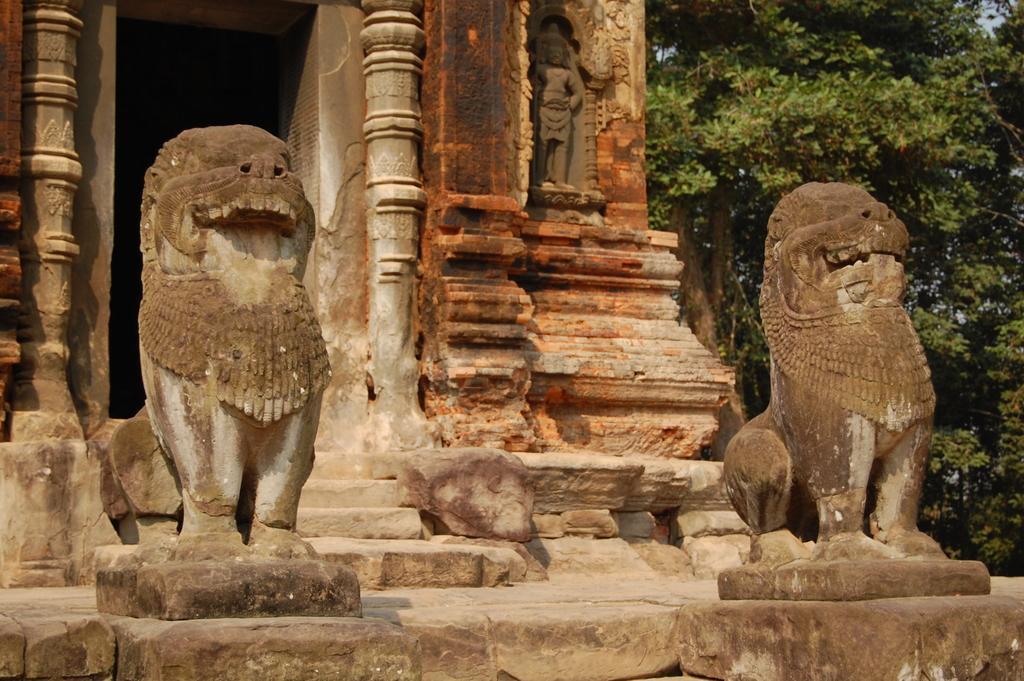Can you describe this image briefly? In the picture we can see a historical temple construction with two lion sculptures near it and besides it we can see trees. 